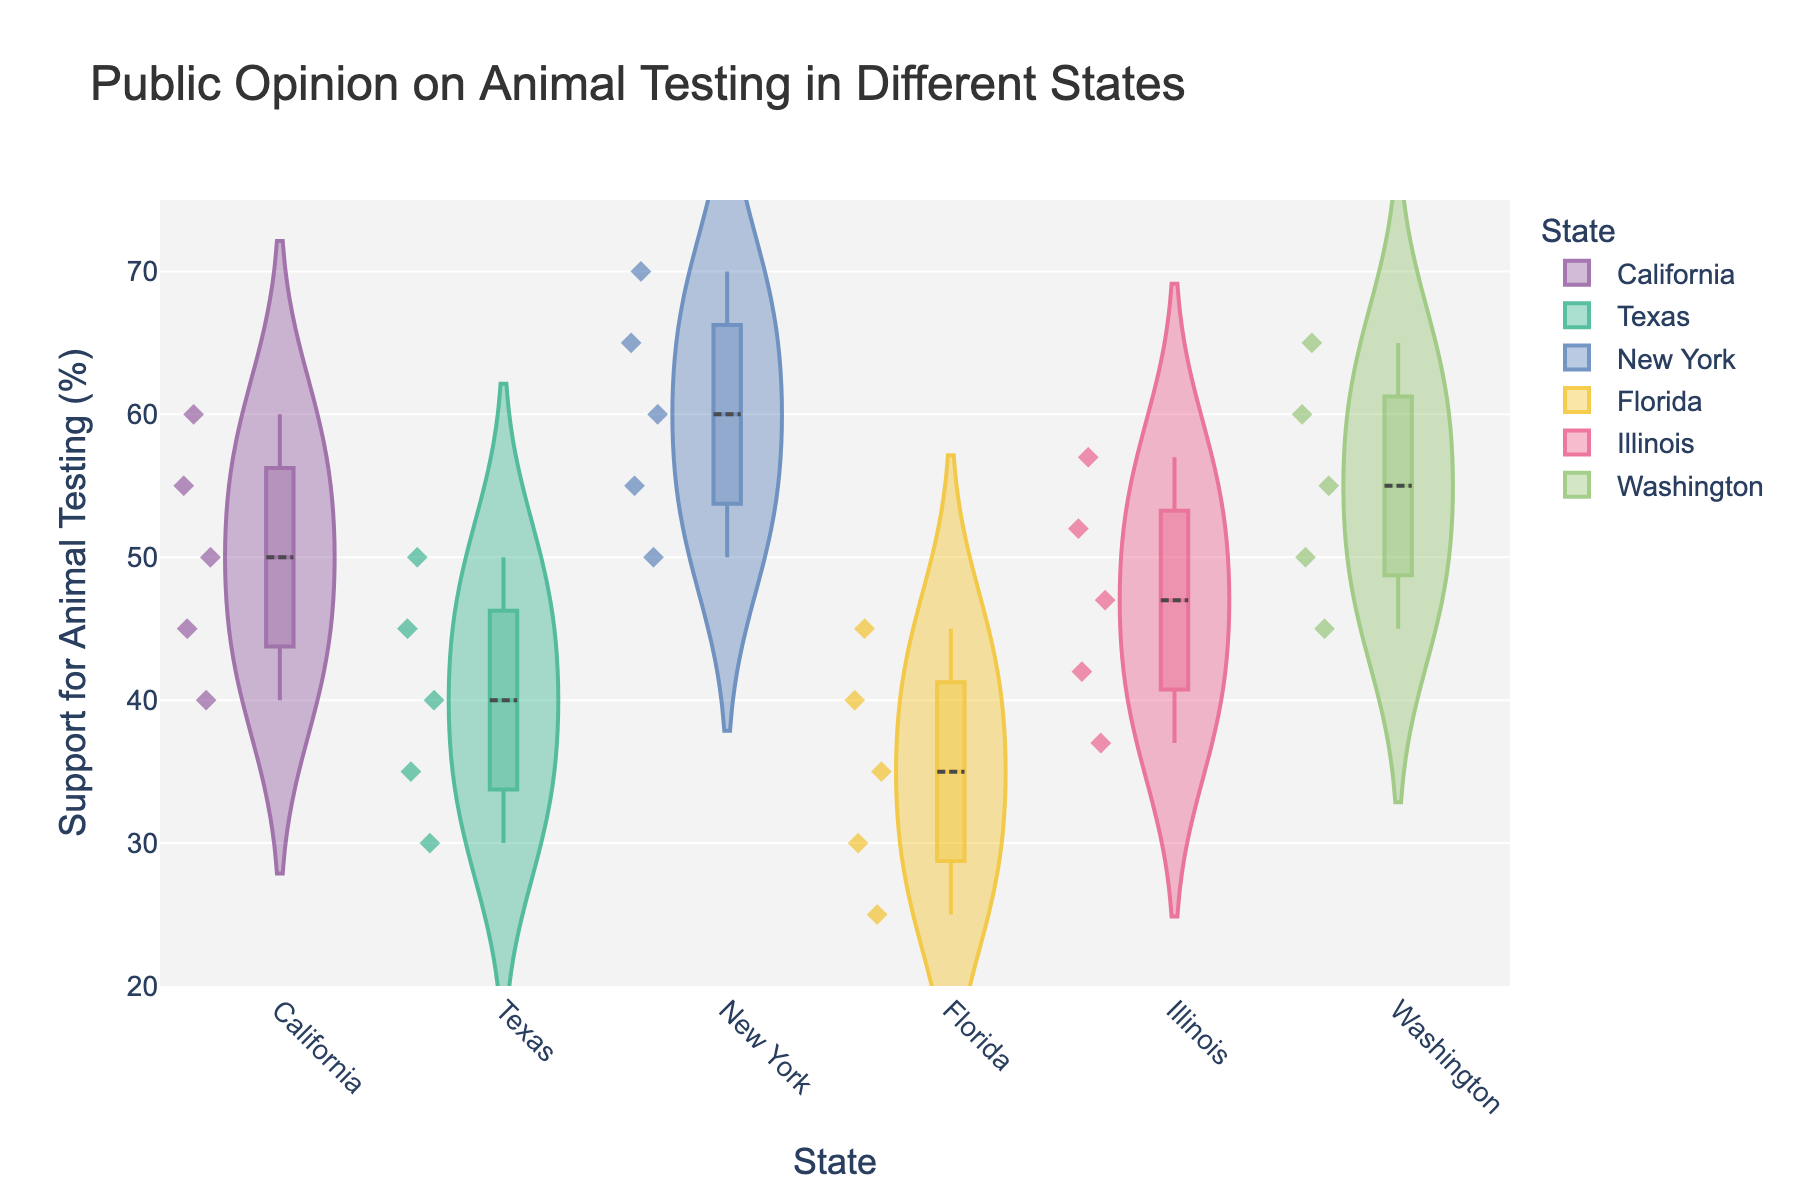What is the title of the figure? The title of the figure is displayed at the top and clearly states what the chart represents.
Answer: Public Opinion on Animal Testing in Different States Which state has the highest median public opinion percentage? From the violin plots, the state with the highest median line visible within the violin shapes is New York.
Answer: New York What is the range of public opinion percentages in Texas? To find the range, observe the lowest and highest data points in the Texas violin plot. The lowest point is 30%, and the highest is 50%. So, the range is 50 - 30.
Answer: 20% Which state shows the widest variation in public opinion? To determine the state with the widest variation, look for the tallest and widest violin plot. New York's plot spans from 50% to 70%, showing the widest range.
Answer: New York What percentage of public opinion does Florida's median line indicate? The median line inside the Florida violin plot indicates the middle percentage, which falls at 35%.
Answer: 35% Identify two states where the public opinion percentage exceeds 60%? By examining the upper end of the violin plots, one can see that both New York and Washington have public opinion percentages that exceed 60%.
Answer: New York, Washington Which state has the lowest minimum public opinion percentage? By identifying the lowest point in each violin plot, one can see that Florida has the minimum value of 25%.
Answer: Florida What does the box inside each violin plot represent? The box inside the violin plot shows the interquartile range (IQR), which includes the middle 50% of the data points.
Answer: Interquartile range Compare the median public opinion percentage between California and Illinois. Observing the median lines within the violin plots for California and Illinois, California is around 50%, while Illinois is approximately 47%.
Answer: California: 50%, Illinois: 47% Which state has the tightest interquartile range (IQR), indicating least variability around the median? The state with the smallest box (IQR) within the violin plot indicates the least variability. Washington's IQR appears tightest.
Answer: Washington 